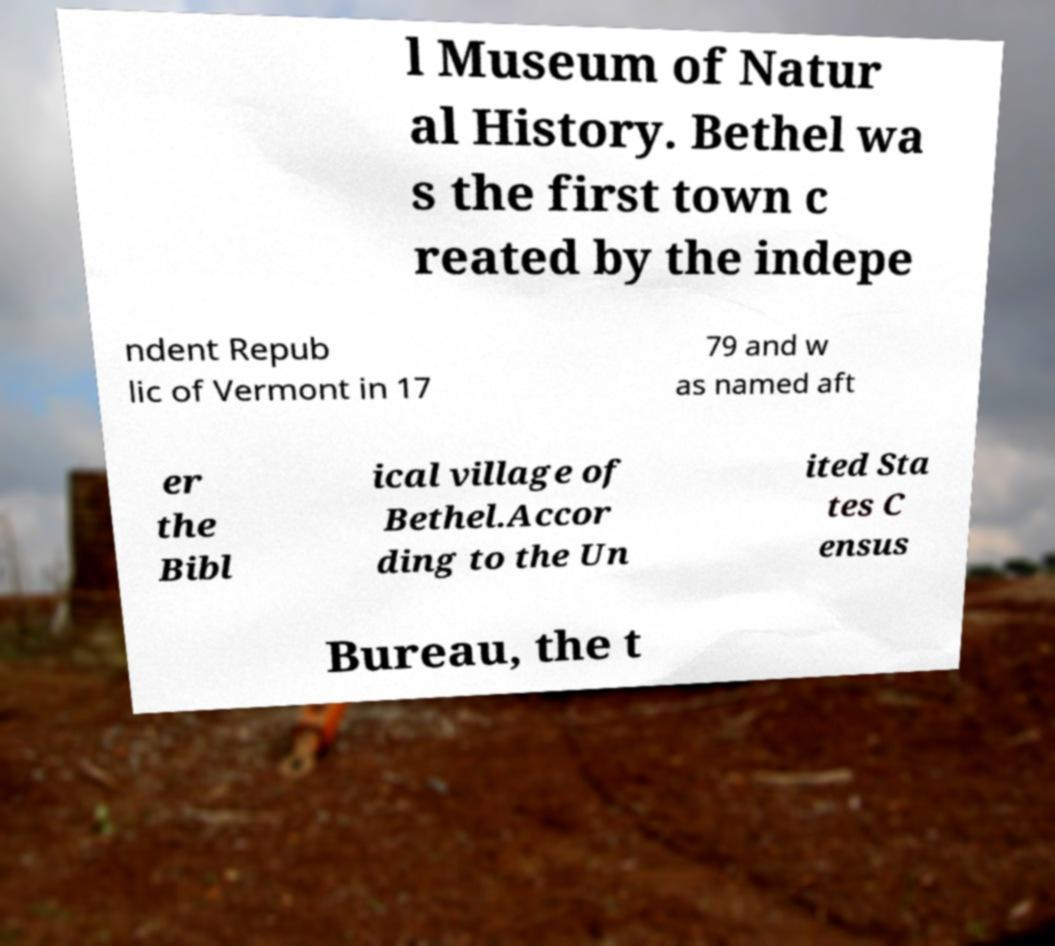Please read and relay the text visible in this image. What does it say? l Museum of Natur al History. Bethel wa s the first town c reated by the indepe ndent Repub lic of Vermont in 17 79 and w as named aft er the Bibl ical village of Bethel.Accor ding to the Un ited Sta tes C ensus Bureau, the t 